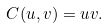<formula> <loc_0><loc_0><loc_500><loc_500>C ( u , v ) = u v .</formula> 